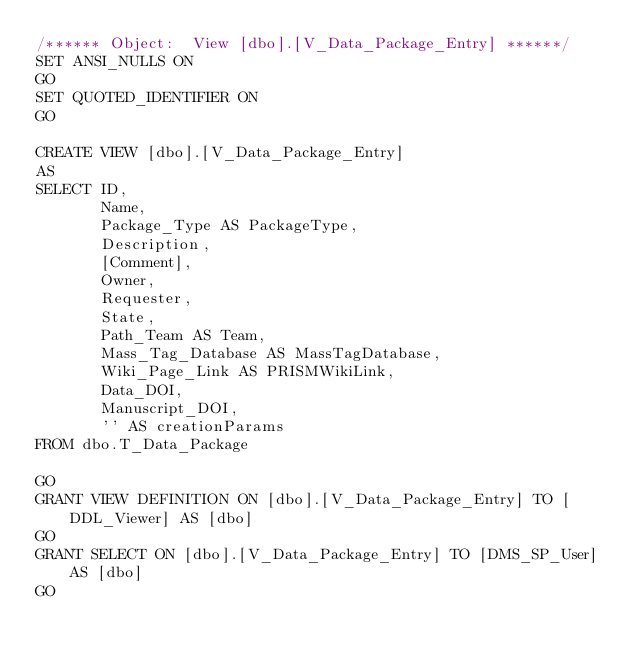<code> <loc_0><loc_0><loc_500><loc_500><_SQL_>/****** Object:  View [dbo].[V_Data_Package_Entry] ******/
SET ANSI_NULLS ON
GO
SET QUOTED_IDENTIFIER ON
GO

CREATE VIEW [dbo].[V_Data_Package_Entry]
AS
SELECT ID,
       Name,
       Package_Type AS PackageType,
       Description,
       [Comment],
       Owner,
       Requester,
       State,
       Path_Team AS Team,
       Mass_Tag_Database AS MassTagDatabase,
       Wiki_Page_Link AS PRISMWikiLink,
       Data_DOI,
       Manuscript_DOI,
       '' AS creationParams
FROM dbo.T_Data_Package

GO
GRANT VIEW DEFINITION ON [dbo].[V_Data_Package_Entry] TO [DDL_Viewer] AS [dbo]
GO
GRANT SELECT ON [dbo].[V_Data_Package_Entry] TO [DMS_SP_User] AS [dbo]
GO
</code> 